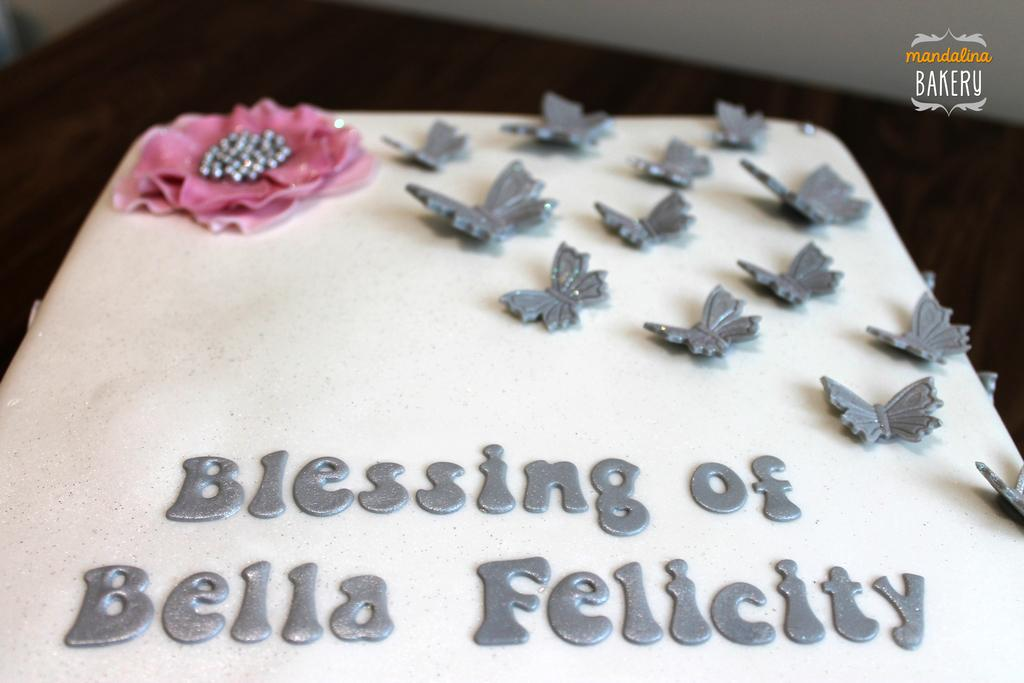What is the main subject in the center of the image? There is a cake in the center of the image. What can be seen in the background of the image? There is a table in the background of the image. Are there any words or letters visible in the image? Yes, there is some text visible in the background of the image. What type of kite is being used to wash the industry in the image? There is no kite or industry present in the image; it only features a cake and some text in the background. 